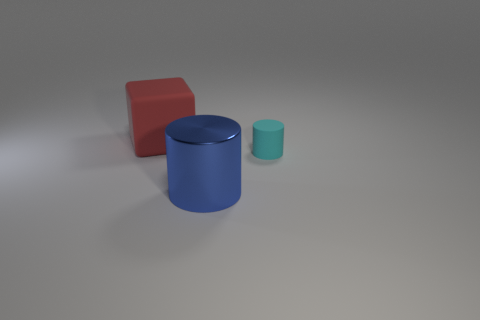What is the cylinder that is behind the big blue object made of? The cylinder behind the large blue object appears to be made of a material similar to the blue object, likely a matte plastic or a similar synthetic material. 